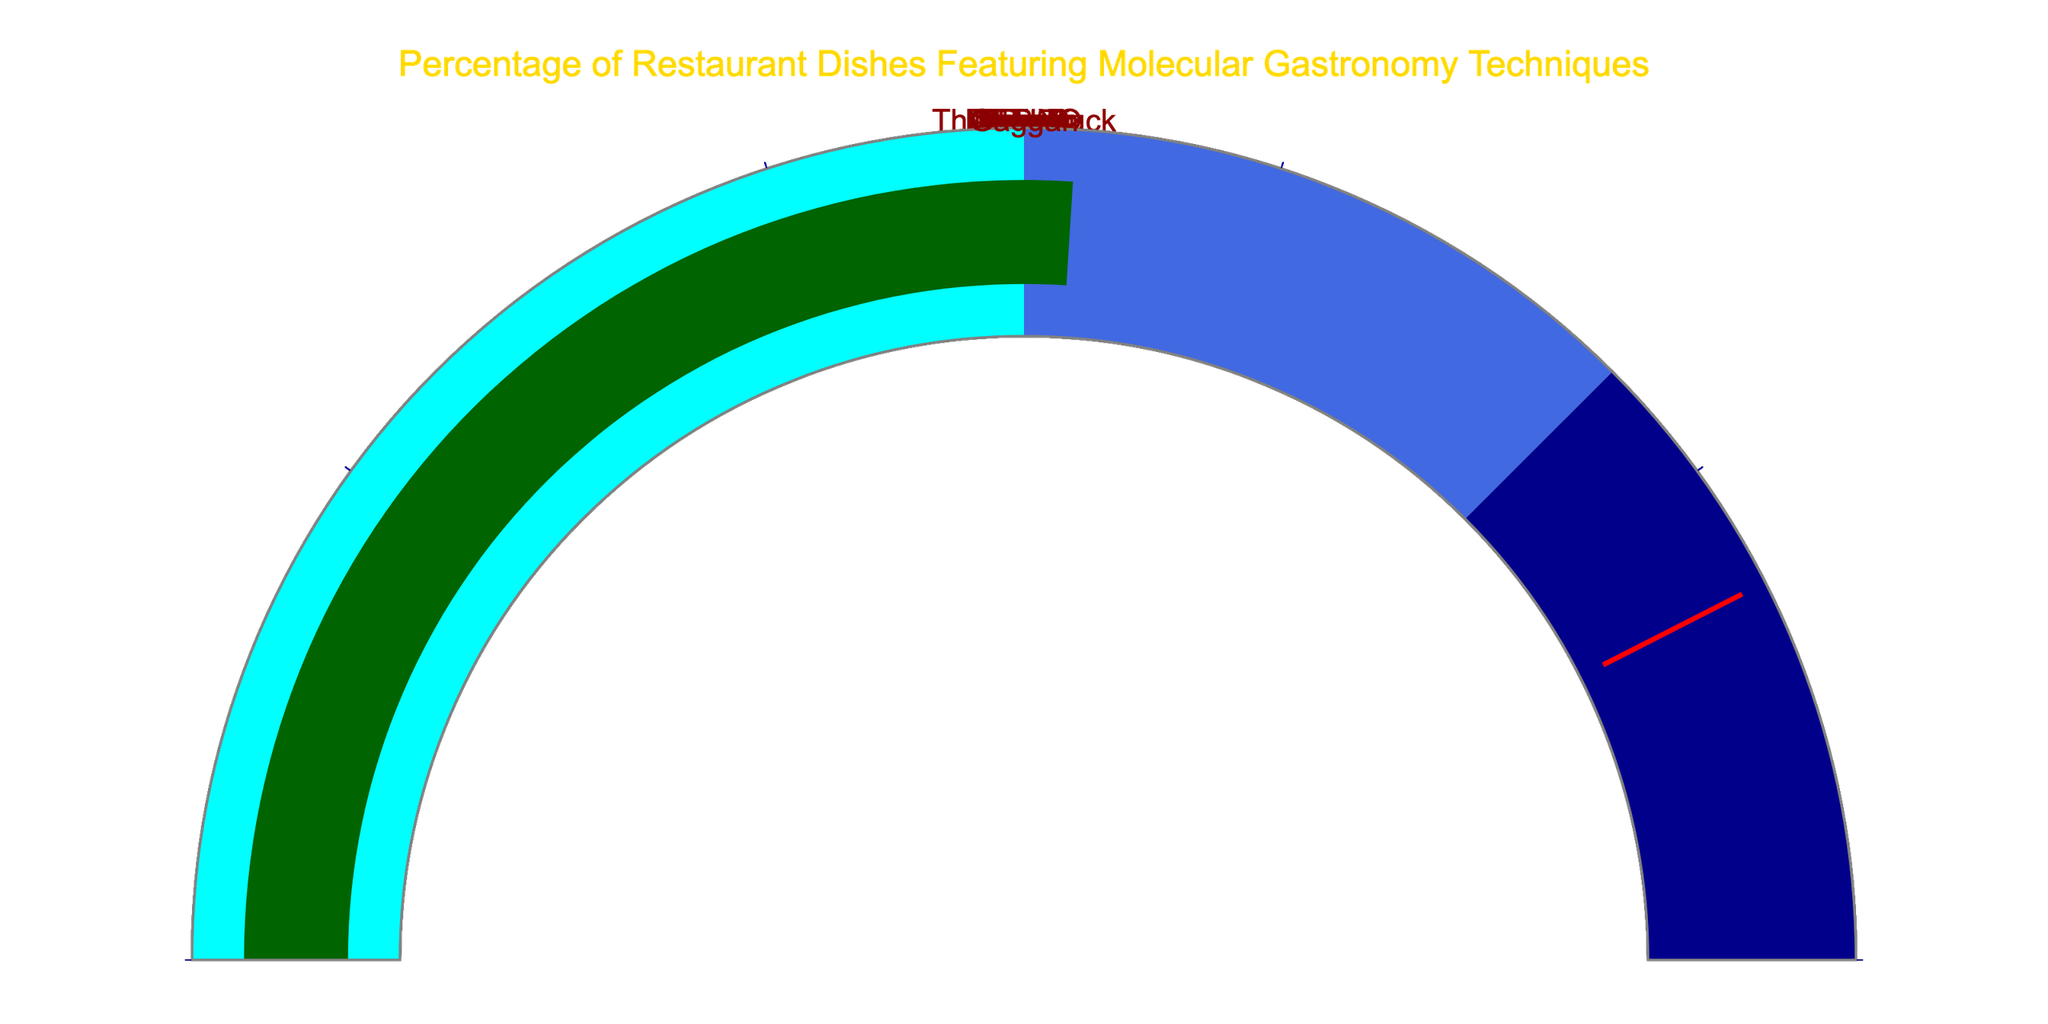How many restaurants are represented in the gauge charts? Count the number of distinct restaurant names in the gauge charts. There are 10 restaurants in the dataset: El Bulli, The Fat Duck, Alinea, wd~50, Noma, Mugaritz, Minibar, Tickets, DiverXO, and Gaggan.
Answer: 10 Which restaurant features the highest percentage of molecular gastronomy techniques? Compare the percentage values displayed on each gauge chart. El Bulli has the highest percentage, which is 85%.
Answer: El Bulli What is the average percentage of molecular gastronomy techniques used across all restaurants? Sum all the percentages and divide by the number of restaurants. The calculation is (85 + 72 + 68 + 60 + 45 + 55 + 70 + 48 + 58 + 52)/10 which equals 61.3%
Answer: 61.3% How many restaurants have a percentage over 50%? Count the number of gauge charts where the percentage value is more than 50. These are El Bulli, The Fat Duck, Alinea, wd~50, Mugaritz, Minibar, and DiverXO, which totals 7.
Answer: 7 Which restaurant has the lowest percentage of molecular gastronomy techniques, and what is that percentage? Compare the percentage values on each gauge chart to find the minimum. Noma has the lowest percentage, which is 45%.
Answer: Noma, 45% What is the median value of percentages across all restaurants? Sort the percentages and find the median value, which is the middle value in a list. In a list of [45, 48, 52, 55, 58, 60, 68, 70, 72, 85], the median value lies between 58 and 60. Average these values (58 + 60)/2 = 59.
Answer: 59 Which restaurant has a percentage closest to the average percentage? Calculate the average (61.3%), then identify which restaurant's percentage is nearest to this value. wd~50 with 60% is the closest to the average.
Answer: wd~50 What range of colors represents the percentages on the gauge charts? Observe the color coding on the gauges. Percentages from 0 to 50 are cyan, from 50 to 75 are royal blue, and from 75 to 100 are dark blue.
Answer: Cyan, Royal Blue, Dark Blue Between The Fat Duck and Alinea, which restaurant features a higher percentage of molecular gastronomy techniques and by how much? Compare the percentages for The Fat Duck (72%) and Alinea (68%). The Fat Duck has a higher percentage by (72 - 68) = 4%.
Answer: The Fat Duck, 4% How many restaurants fall into the highest percentage range (over 75%)? Identify the gauge charts labeled from 75 to 100. Only El Bulli falls into this range with 85%.
Answer: 1 